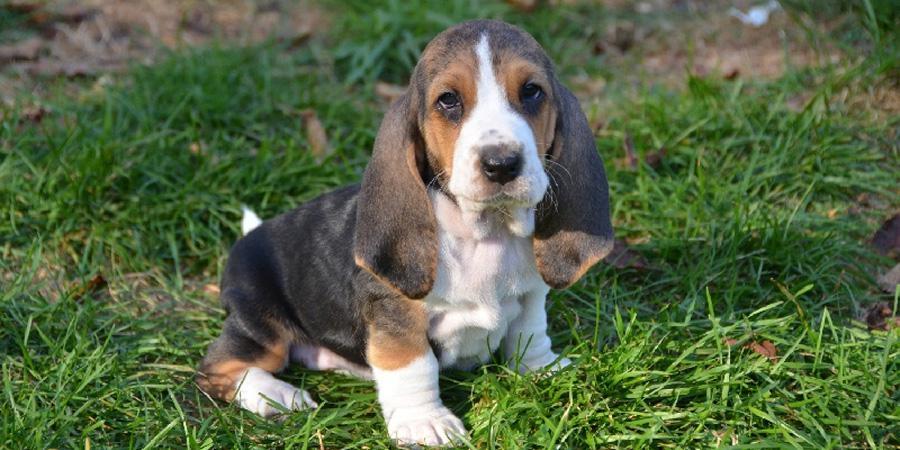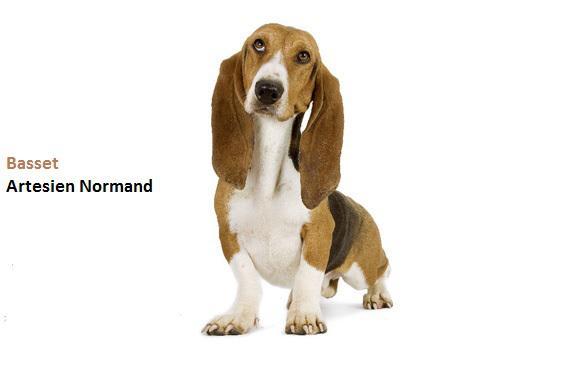The first image is the image on the left, the second image is the image on the right. Examine the images to the left and right. Is the description "Each image shows one standing basset hound, and one image includes a person with hands at the front and back of the dog." accurate? Answer yes or no. No. The first image is the image on the left, the second image is the image on the right. For the images displayed, is the sentence "there is a beagle outside on the grass" factually correct? Answer yes or no. Yes. 